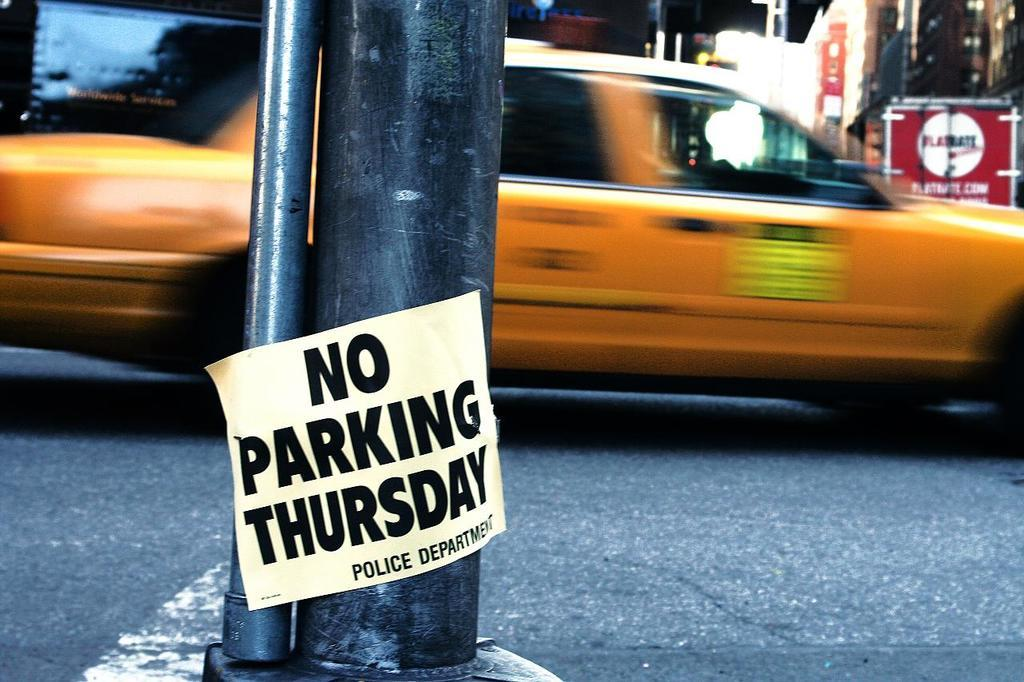<image>
Describe the image concisely. A sign that says No Parking Thursday is on the side of the street in a busy city. 